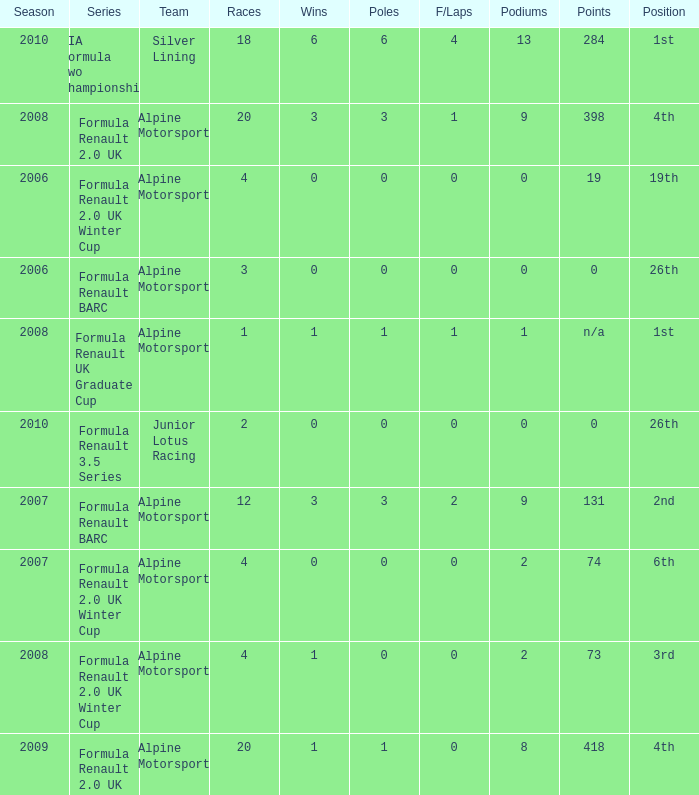How much were the f/laps if poles is higher than 1.0 during 2008? 1.0. 